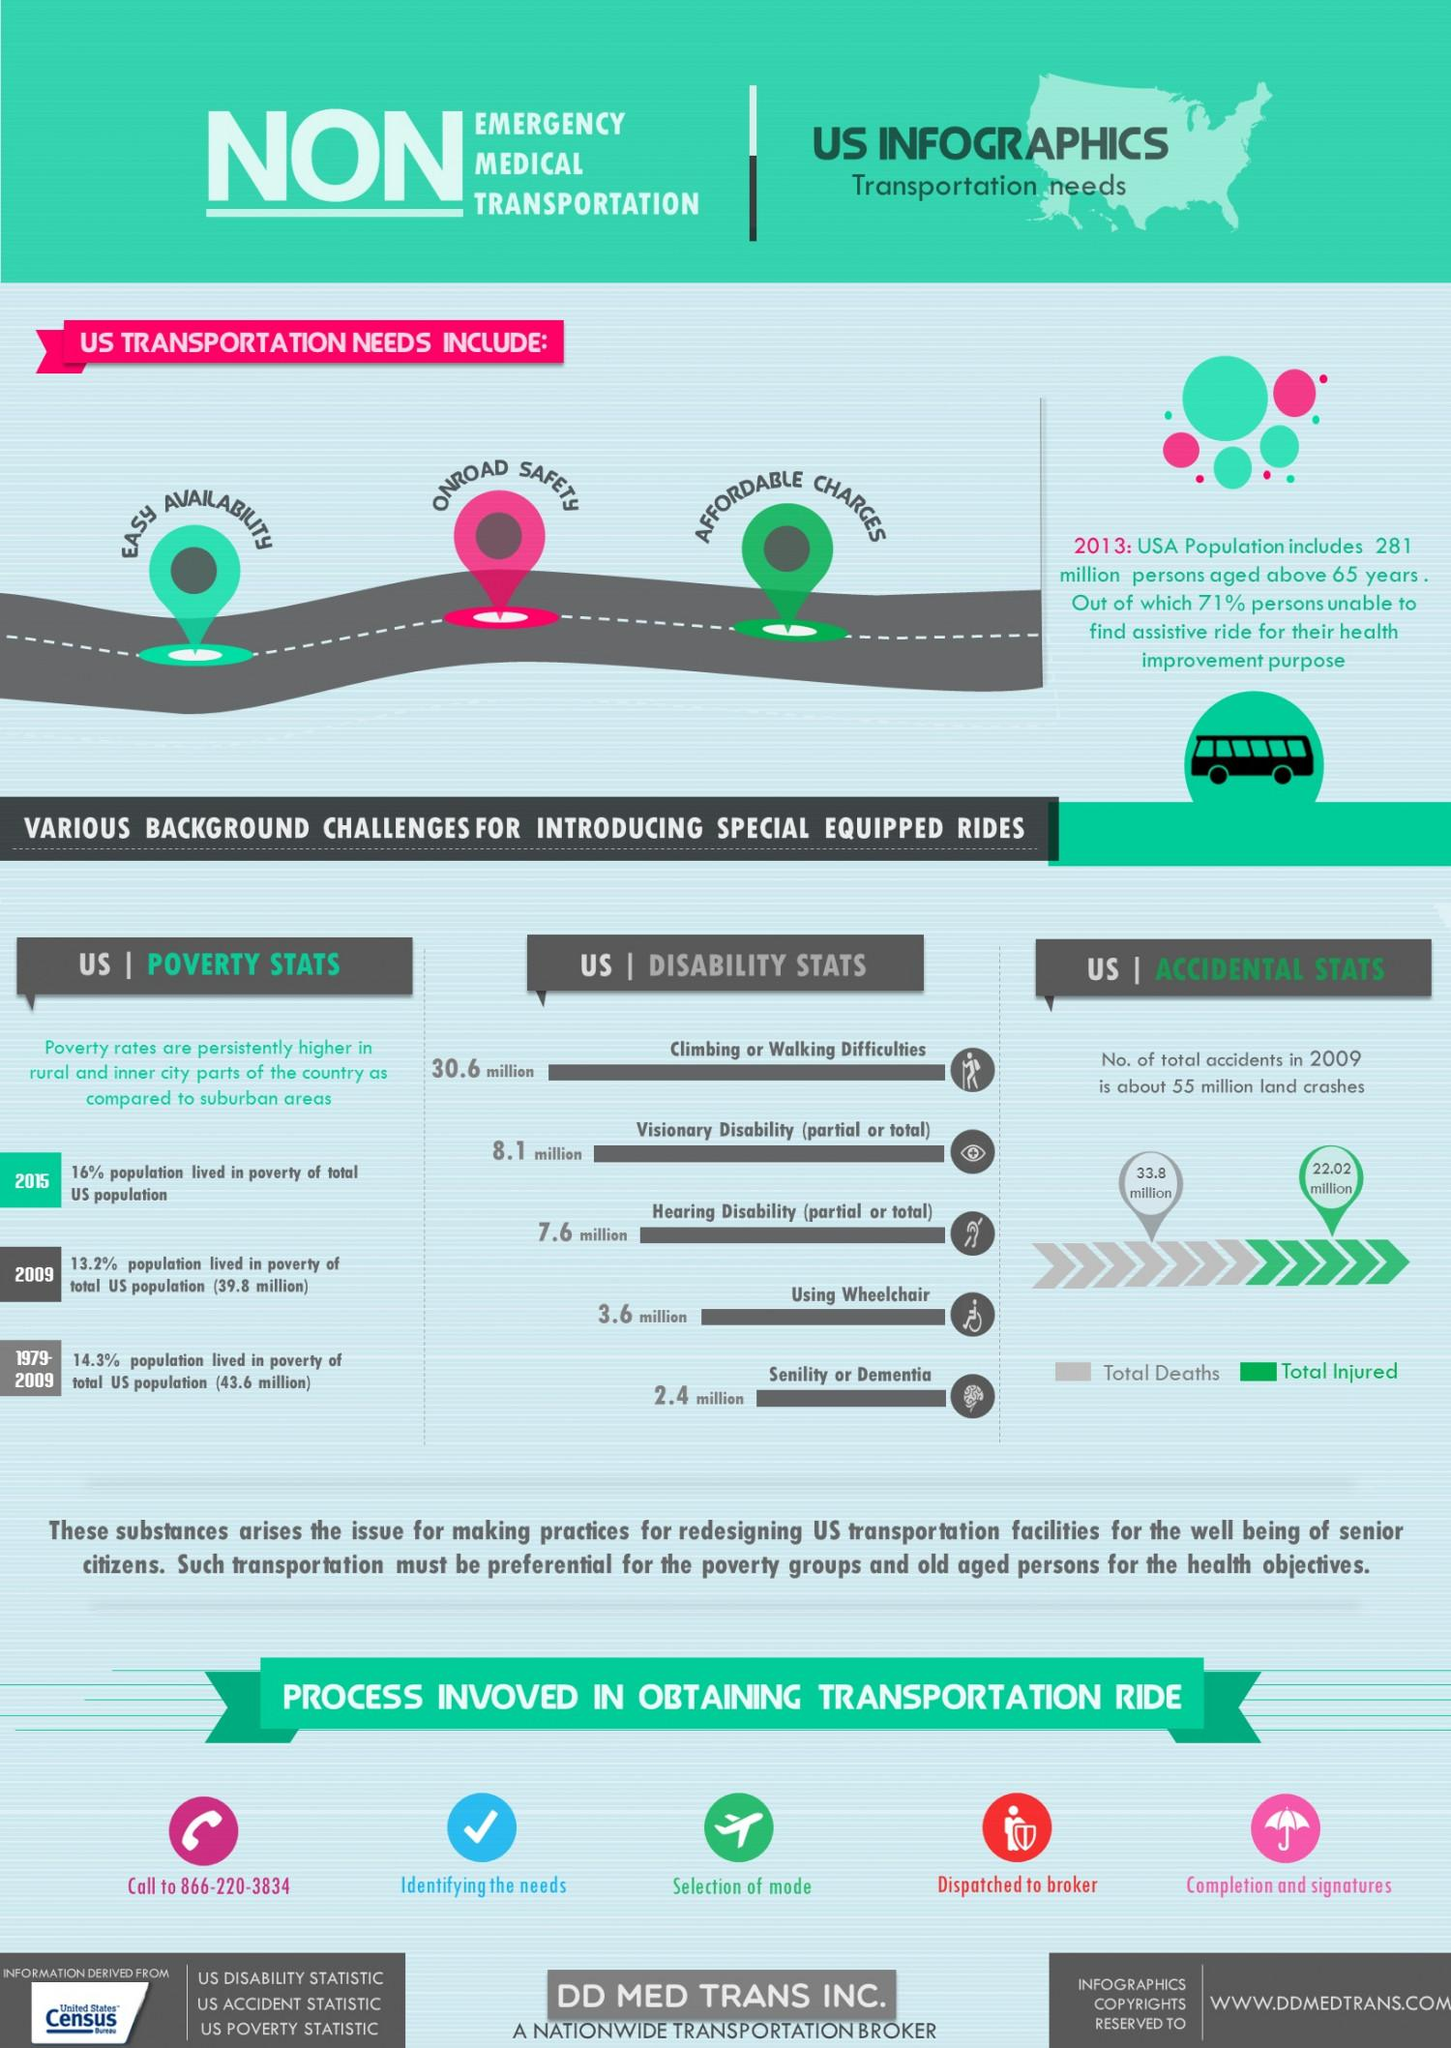Indicate a few pertinent items in this graphic. There are approximately 10.5 million people in the United States who have visionary disability and senility. The umbrella demonstrates the completion and signatures process. The aeroplane demonstrates the process of selection of mode. The difference between total deaths and total injured is 11.78. In 2009, there was a reduction in the poverty rate. 